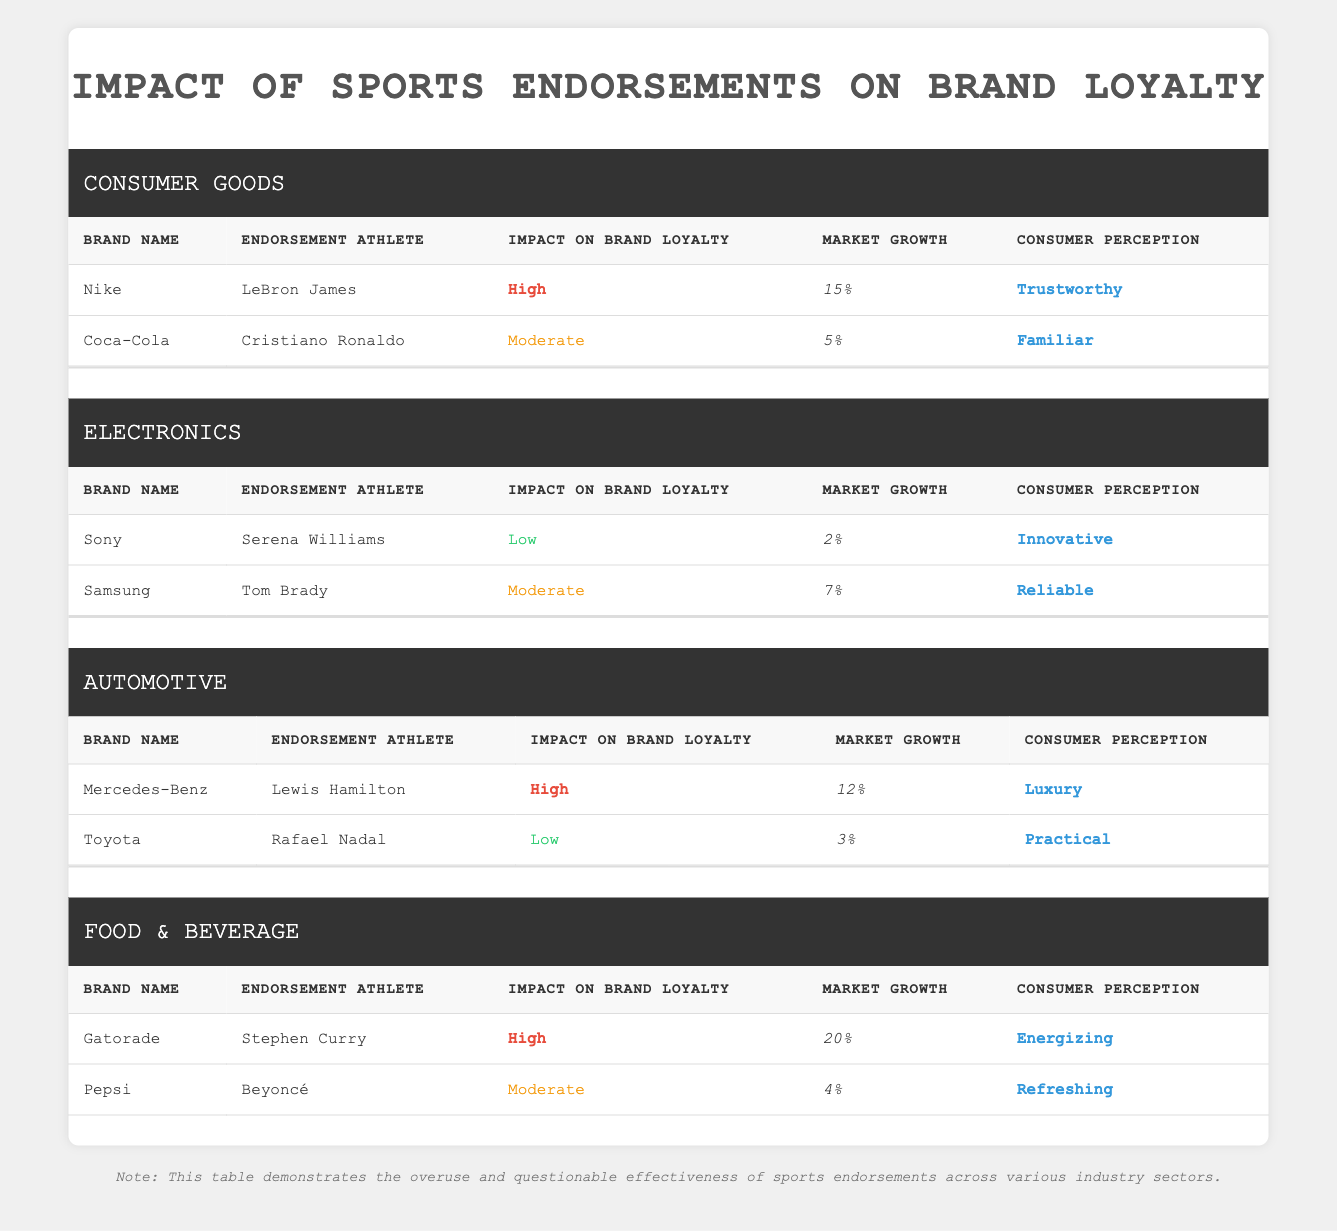What is the impact on brand loyalty for Nike? According to the table, Nike has an impact on brand loyalty rated as "High" when endorsed by LeBron James.
Answer: High Which brand has the highest market growth among all the brands listed? Examining the market growth percentages, Gatorade shows the highest growth at 20%. Hence, Gatorade has the highest market growth.
Answer: Gatorade Is Coca-Cola's endorsement athlete Cristiano Ronaldo associated with high impact on brand loyalty? The table shows that Coca-Cola has a "Moderate" impact on brand loyalty with Cristiano Ronaldo, which indicates that it is not high.
Answer: No How many brands in the Automotive sector have a low impact on brand loyalty? In the Automotive sector, there are two brands: Mercedes-Benz with high impact and Toyota with low impact. Thus, only one brand (Toyota) has a low impact.
Answer: 1 What is the average market growth for the Electronics sector? The market growth percentages for the Electronics sector are 2% (Sony) and 7% (Samsung). Adding these gives us 9%, and dividing by the number of brands (2) results in an average of 4.5%.
Answer: 4.5% Which brand has the best consumer perception in the Consumer Goods sector? In the Consumer Goods sector, Nike is described as "Trustworthy," while Coca-Cola is labeled "Familiar." Comparing these descriptors, "Trustworthy" generally indicates a better consumer perception.
Answer: Nike Are all brands in the Food & Beverage sector associated with high impact on brand loyalty? The table indicates that Gatorade has high impact while Pepsi has moderate impact. Therefore, not all brands are associated with high impact.
Answer: No What percentage of market growth does the brand Toyota have? In the table, Toyota's market growth is listed as 3%.
Answer: 3% How does the impact on brand loyalty of Mercedes-Benz compare to that of Toyota? Mercedes-Benz has a high impact on brand loyalty while Toyota has a low impact. This shows a clear difference, with Mercedes-Benz being much more positively viewed in this aspect.
Answer: Higher 